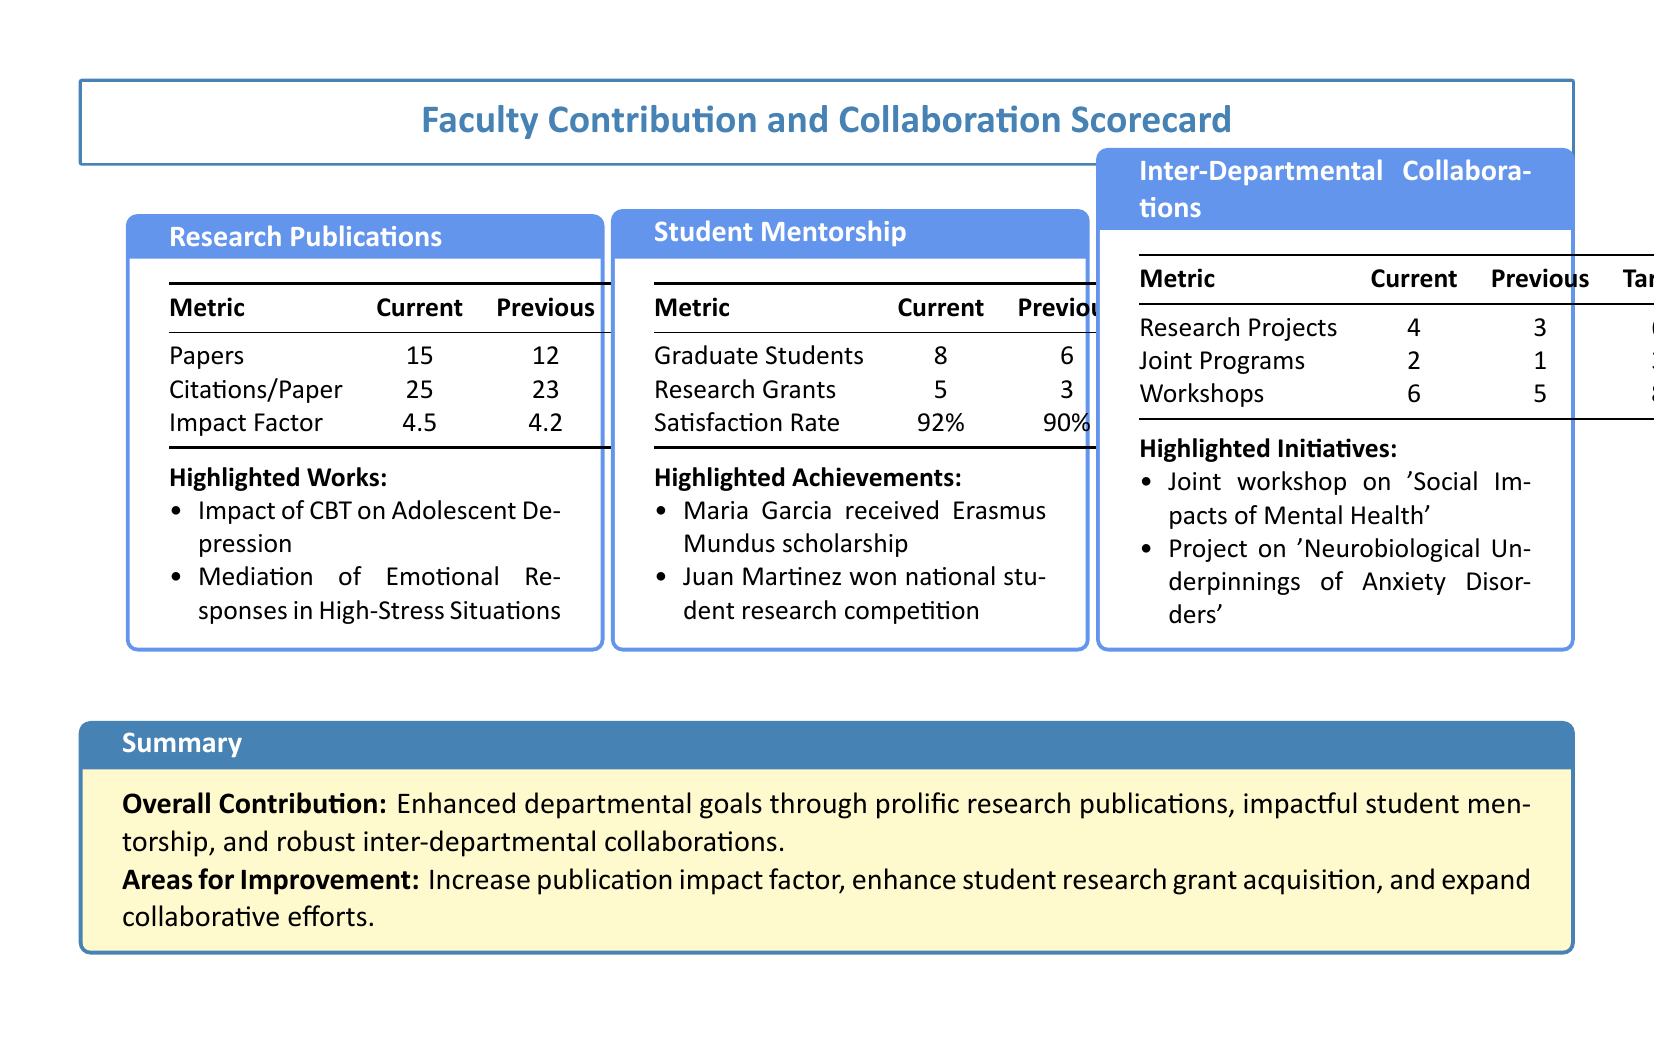What is the current number of research papers published? The current number of research papers published is directly stated in the scorecard under Research Publications.
Answer: 15 What was the satisfaction rate for student mentorship in the previous period? The previous satisfaction rate is indicated in the Student Mentorship section of the document.
Answer: 90% How many graduate students are currently being mentored? The current number of graduate students is specified in the Student Mentorship section.
Answer: 8 What is the target impact factor for research publications? The target impact factor is listed in the Research Publications table in the scorecard.
Answer: 5.0 How many joint programs have been established currently? The current number of joint programs is found in the Inter-Departmental Collaborations section.
Answer: 2 What is the number of citations per paper in the previous period? The number of citations per paper for the previous period is detailed in the Research Publications section.
Answer: 23 What highlighted work focuses on adolescent depression? The specific highlighted work is listed under Research Publications.
Answer: Impact of CBT on Adolescent Depression How many workshops have been conducted in the current period? The number of workshops is presented in the Inter-Departmental Collaborations section.
Answer: 6 What notable student achievement is mentioned in the document? This information can be found in the Student Mentorship section, detailing a specific student's achievement.
Answer: Maria Garcia received Erasmus Mundus scholarship 